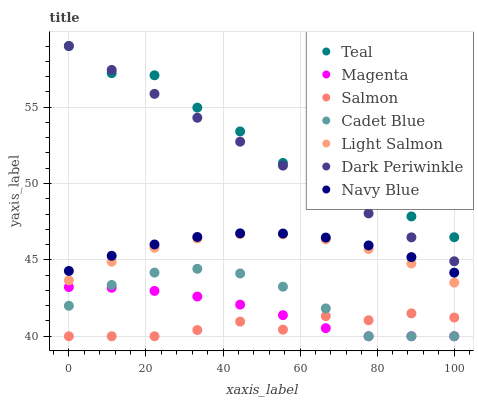Does Salmon have the minimum area under the curve?
Answer yes or no. Yes. Does Teal have the maximum area under the curve?
Answer yes or no. Yes. Does Cadet Blue have the minimum area under the curve?
Answer yes or no. No. Does Cadet Blue have the maximum area under the curve?
Answer yes or no. No. Is Dark Periwinkle the smoothest?
Answer yes or no. Yes. Is Teal the roughest?
Answer yes or no. Yes. Is Cadet Blue the smoothest?
Answer yes or no. No. Is Cadet Blue the roughest?
Answer yes or no. No. Does Cadet Blue have the lowest value?
Answer yes or no. Yes. Does Navy Blue have the lowest value?
Answer yes or no. No. Does Dark Periwinkle have the highest value?
Answer yes or no. Yes. Does Cadet Blue have the highest value?
Answer yes or no. No. Is Magenta less than Teal?
Answer yes or no. Yes. Is Navy Blue greater than Magenta?
Answer yes or no. Yes. Does Magenta intersect Cadet Blue?
Answer yes or no. Yes. Is Magenta less than Cadet Blue?
Answer yes or no. No. Is Magenta greater than Cadet Blue?
Answer yes or no. No. Does Magenta intersect Teal?
Answer yes or no. No. 